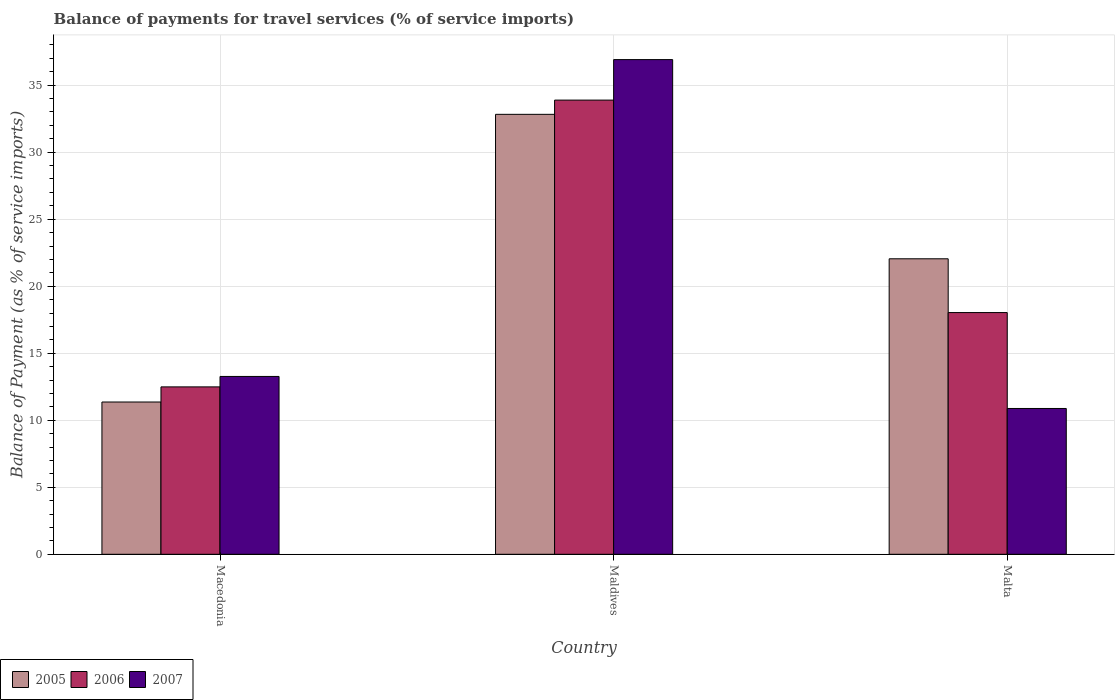How many different coloured bars are there?
Keep it short and to the point. 3. How many groups of bars are there?
Provide a succinct answer. 3. Are the number of bars per tick equal to the number of legend labels?
Provide a succinct answer. Yes. How many bars are there on the 2nd tick from the left?
Ensure brevity in your answer.  3. How many bars are there on the 2nd tick from the right?
Offer a very short reply. 3. What is the label of the 3rd group of bars from the left?
Make the answer very short. Malta. What is the balance of payments for travel services in 2006 in Maldives?
Make the answer very short. 33.89. Across all countries, what is the maximum balance of payments for travel services in 2005?
Your response must be concise. 32.82. Across all countries, what is the minimum balance of payments for travel services in 2005?
Your answer should be compact. 11.36. In which country was the balance of payments for travel services in 2005 maximum?
Your answer should be very brief. Maldives. In which country was the balance of payments for travel services in 2005 minimum?
Offer a very short reply. Macedonia. What is the total balance of payments for travel services in 2007 in the graph?
Provide a short and direct response. 61.05. What is the difference between the balance of payments for travel services in 2006 in Macedonia and that in Malta?
Offer a very short reply. -5.54. What is the difference between the balance of payments for travel services in 2007 in Malta and the balance of payments for travel services in 2005 in Maldives?
Provide a short and direct response. -21.95. What is the average balance of payments for travel services in 2007 per country?
Offer a very short reply. 20.35. What is the difference between the balance of payments for travel services of/in 2007 and balance of payments for travel services of/in 2005 in Macedonia?
Give a very brief answer. 1.91. What is the ratio of the balance of payments for travel services in 2005 in Macedonia to that in Maldives?
Make the answer very short. 0.35. Is the difference between the balance of payments for travel services in 2007 in Macedonia and Maldives greater than the difference between the balance of payments for travel services in 2005 in Macedonia and Maldives?
Your response must be concise. No. What is the difference between the highest and the second highest balance of payments for travel services in 2005?
Make the answer very short. 21.46. What is the difference between the highest and the lowest balance of payments for travel services in 2007?
Ensure brevity in your answer.  26.03. What does the 3rd bar from the left in Malta represents?
Keep it short and to the point. 2007. What does the 1st bar from the right in Malta represents?
Provide a short and direct response. 2007. How many bars are there?
Your response must be concise. 9. How many countries are there in the graph?
Provide a short and direct response. 3. Are the values on the major ticks of Y-axis written in scientific E-notation?
Make the answer very short. No. Does the graph contain any zero values?
Your response must be concise. No. What is the title of the graph?
Keep it short and to the point. Balance of payments for travel services (% of service imports). What is the label or title of the Y-axis?
Offer a terse response. Balance of Payment (as % of service imports). What is the Balance of Payment (as % of service imports) in 2005 in Macedonia?
Your answer should be compact. 11.36. What is the Balance of Payment (as % of service imports) in 2006 in Macedonia?
Your answer should be very brief. 12.49. What is the Balance of Payment (as % of service imports) of 2007 in Macedonia?
Your response must be concise. 13.27. What is the Balance of Payment (as % of service imports) in 2005 in Maldives?
Your response must be concise. 32.82. What is the Balance of Payment (as % of service imports) of 2006 in Maldives?
Provide a succinct answer. 33.89. What is the Balance of Payment (as % of service imports) of 2007 in Maldives?
Provide a succinct answer. 36.91. What is the Balance of Payment (as % of service imports) of 2005 in Malta?
Your response must be concise. 22.05. What is the Balance of Payment (as % of service imports) in 2006 in Malta?
Ensure brevity in your answer.  18.03. What is the Balance of Payment (as % of service imports) of 2007 in Malta?
Offer a very short reply. 10.88. Across all countries, what is the maximum Balance of Payment (as % of service imports) of 2005?
Your response must be concise. 32.82. Across all countries, what is the maximum Balance of Payment (as % of service imports) of 2006?
Offer a terse response. 33.89. Across all countries, what is the maximum Balance of Payment (as % of service imports) of 2007?
Give a very brief answer. 36.91. Across all countries, what is the minimum Balance of Payment (as % of service imports) of 2005?
Offer a very short reply. 11.36. Across all countries, what is the minimum Balance of Payment (as % of service imports) in 2006?
Your answer should be very brief. 12.49. Across all countries, what is the minimum Balance of Payment (as % of service imports) in 2007?
Your answer should be very brief. 10.88. What is the total Balance of Payment (as % of service imports) of 2005 in the graph?
Your answer should be very brief. 66.23. What is the total Balance of Payment (as % of service imports) of 2006 in the graph?
Offer a terse response. 64.41. What is the total Balance of Payment (as % of service imports) in 2007 in the graph?
Offer a terse response. 61.05. What is the difference between the Balance of Payment (as % of service imports) in 2005 in Macedonia and that in Maldives?
Provide a short and direct response. -21.46. What is the difference between the Balance of Payment (as % of service imports) in 2006 in Macedonia and that in Maldives?
Keep it short and to the point. -21.4. What is the difference between the Balance of Payment (as % of service imports) of 2007 in Macedonia and that in Maldives?
Offer a terse response. -23.64. What is the difference between the Balance of Payment (as % of service imports) of 2005 in Macedonia and that in Malta?
Your answer should be compact. -10.68. What is the difference between the Balance of Payment (as % of service imports) in 2006 in Macedonia and that in Malta?
Provide a succinct answer. -5.54. What is the difference between the Balance of Payment (as % of service imports) in 2007 in Macedonia and that in Malta?
Your response must be concise. 2.39. What is the difference between the Balance of Payment (as % of service imports) in 2005 in Maldives and that in Malta?
Give a very brief answer. 10.78. What is the difference between the Balance of Payment (as % of service imports) in 2006 in Maldives and that in Malta?
Offer a very short reply. 15.85. What is the difference between the Balance of Payment (as % of service imports) in 2007 in Maldives and that in Malta?
Offer a terse response. 26.03. What is the difference between the Balance of Payment (as % of service imports) of 2005 in Macedonia and the Balance of Payment (as % of service imports) of 2006 in Maldives?
Give a very brief answer. -22.52. What is the difference between the Balance of Payment (as % of service imports) of 2005 in Macedonia and the Balance of Payment (as % of service imports) of 2007 in Maldives?
Keep it short and to the point. -25.55. What is the difference between the Balance of Payment (as % of service imports) of 2006 in Macedonia and the Balance of Payment (as % of service imports) of 2007 in Maldives?
Your response must be concise. -24.42. What is the difference between the Balance of Payment (as % of service imports) in 2005 in Macedonia and the Balance of Payment (as % of service imports) in 2006 in Malta?
Offer a terse response. -6.67. What is the difference between the Balance of Payment (as % of service imports) in 2005 in Macedonia and the Balance of Payment (as % of service imports) in 2007 in Malta?
Provide a succinct answer. 0.48. What is the difference between the Balance of Payment (as % of service imports) of 2006 in Macedonia and the Balance of Payment (as % of service imports) of 2007 in Malta?
Your response must be concise. 1.61. What is the difference between the Balance of Payment (as % of service imports) in 2005 in Maldives and the Balance of Payment (as % of service imports) in 2006 in Malta?
Keep it short and to the point. 14.79. What is the difference between the Balance of Payment (as % of service imports) in 2005 in Maldives and the Balance of Payment (as % of service imports) in 2007 in Malta?
Provide a short and direct response. 21.95. What is the difference between the Balance of Payment (as % of service imports) of 2006 in Maldives and the Balance of Payment (as % of service imports) of 2007 in Malta?
Keep it short and to the point. 23.01. What is the average Balance of Payment (as % of service imports) in 2005 per country?
Provide a succinct answer. 22.08. What is the average Balance of Payment (as % of service imports) of 2006 per country?
Your answer should be very brief. 21.47. What is the average Balance of Payment (as % of service imports) in 2007 per country?
Give a very brief answer. 20.35. What is the difference between the Balance of Payment (as % of service imports) of 2005 and Balance of Payment (as % of service imports) of 2006 in Macedonia?
Provide a succinct answer. -1.13. What is the difference between the Balance of Payment (as % of service imports) in 2005 and Balance of Payment (as % of service imports) in 2007 in Macedonia?
Your answer should be compact. -1.91. What is the difference between the Balance of Payment (as % of service imports) in 2006 and Balance of Payment (as % of service imports) in 2007 in Macedonia?
Your answer should be compact. -0.78. What is the difference between the Balance of Payment (as % of service imports) of 2005 and Balance of Payment (as % of service imports) of 2006 in Maldives?
Offer a very short reply. -1.06. What is the difference between the Balance of Payment (as % of service imports) of 2005 and Balance of Payment (as % of service imports) of 2007 in Maldives?
Your response must be concise. -4.08. What is the difference between the Balance of Payment (as % of service imports) in 2006 and Balance of Payment (as % of service imports) in 2007 in Maldives?
Keep it short and to the point. -3.02. What is the difference between the Balance of Payment (as % of service imports) of 2005 and Balance of Payment (as % of service imports) of 2006 in Malta?
Give a very brief answer. 4.01. What is the difference between the Balance of Payment (as % of service imports) in 2005 and Balance of Payment (as % of service imports) in 2007 in Malta?
Ensure brevity in your answer.  11.17. What is the difference between the Balance of Payment (as % of service imports) in 2006 and Balance of Payment (as % of service imports) in 2007 in Malta?
Make the answer very short. 7.16. What is the ratio of the Balance of Payment (as % of service imports) of 2005 in Macedonia to that in Maldives?
Provide a succinct answer. 0.35. What is the ratio of the Balance of Payment (as % of service imports) of 2006 in Macedonia to that in Maldives?
Keep it short and to the point. 0.37. What is the ratio of the Balance of Payment (as % of service imports) in 2007 in Macedonia to that in Maldives?
Your answer should be compact. 0.36. What is the ratio of the Balance of Payment (as % of service imports) in 2005 in Macedonia to that in Malta?
Your answer should be very brief. 0.52. What is the ratio of the Balance of Payment (as % of service imports) in 2006 in Macedonia to that in Malta?
Make the answer very short. 0.69. What is the ratio of the Balance of Payment (as % of service imports) of 2007 in Macedonia to that in Malta?
Your response must be concise. 1.22. What is the ratio of the Balance of Payment (as % of service imports) of 2005 in Maldives to that in Malta?
Offer a terse response. 1.49. What is the ratio of the Balance of Payment (as % of service imports) of 2006 in Maldives to that in Malta?
Give a very brief answer. 1.88. What is the ratio of the Balance of Payment (as % of service imports) in 2007 in Maldives to that in Malta?
Offer a terse response. 3.39. What is the difference between the highest and the second highest Balance of Payment (as % of service imports) in 2005?
Make the answer very short. 10.78. What is the difference between the highest and the second highest Balance of Payment (as % of service imports) of 2006?
Make the answer very short. 15.85. What is the difference between the highest and the second highest Balance of Payment (as % of service imports) of 2007?
Ensure brevity in your answer.  23.64. What is the difference between the highest and the lowest Balance of Payment (as % of service imports) of 2005?
Offer a very short reply. 21.46. What is the difference between the highest and the lowest Balance of Payment (as % of service imports) in 2006?
Make the answer very short. 21.4. What is the difference between the highest and the lowest Balance of Payment (as % of service imports) of 2007?
Offer a terse response. 26.03. 